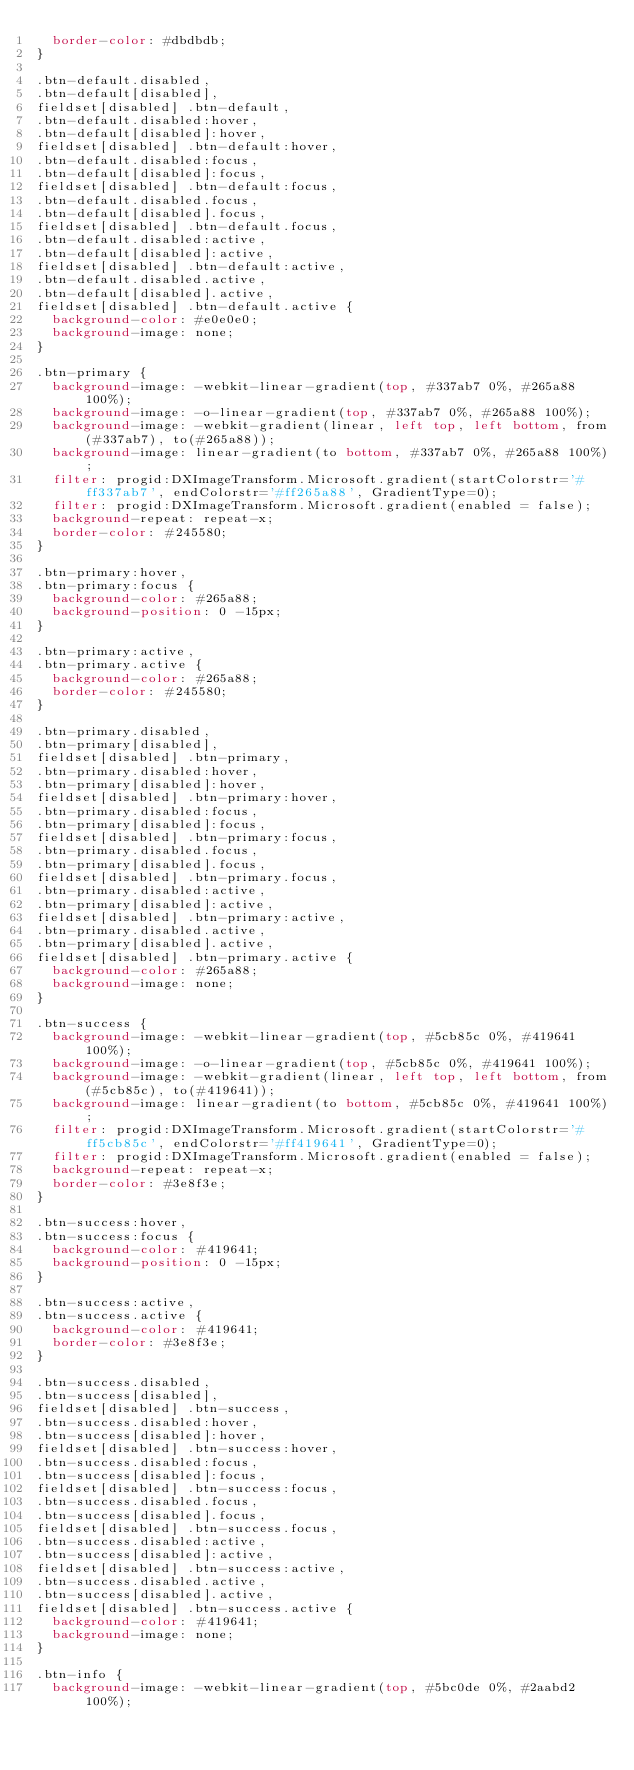Convert code to text. <code><loc_0><loc_0><loc_500><loc_500><_CSS_>  border-color: #dbdbdb;
}

.btn-default.disabled,
.btn-default[disabled],
fieldset[disabled] .btn-default,
.btn-default.disabled:hover,
.btn-default[disabled]:hover,
fieldset[disabled] .btn-default:hover,
.btn-default.disabled:focus,
.btn-default[disabled]:focus,
fieldset[disabled] .btn-default:focus,
.btn-default.disabled.focus,
.btn-default[disabled].focus,
fieldset[disabled] .btn-default.focus,
.btn-default.disabled:active,
.btn-default[disabled]:active,
fieldset[disabled] .btn-default:active,
.btn-default.disabled.active,
.btn-default[disabled].active,
fieldset[disabled] .btn-default.active {
  background-color: #e0e0e0;
  background-image: none;
}

.btn-primary {
  background-image: -webkit-linear-gradient(top, #337ab7 0%, #265a88 100%);
  background-image: -o-linear-gradient(top, #337ab7 0%, #265a88 100%);
  background-image: -webkit-gradient(linear, left top, left bottom, from(#337ab7), to(#265a88));
  background-image: linear-gradient(to bottom, #337ab7 0%, #265a88 100%);
  filter: progid:DXImageTransform.Microsoft.gradient(startColorstr='#ff337ab7', endColorstr='#ff265a88', GradientType=0);
  filter: progid:DXImageTransform.Microsoft.gradient(enabled = false);
  background-repeat: repeat-x;
  border-color: #245580;
}

.btn-primary:hover,
.btn-primary:focus {
  background-color: #265a88;
  background-position: 0 -15px;
}

.btn-primary:active,
.btn-primary.active {
  background-color: #265a88;
  border-color: #245580;
}

.btn-primary.disabled,
.btn-primary[disabled],
fieldset[disabled] .btn-primary,
.btn-primary.disabled:hover,
.btn-primary[disabled]:hover,
fieldset[disabled] .btn-primary:hover,
.btn-primary.disabled:focus,
.btn-primary[disabled]:focus,
fieldset[disabled] .btn-primary:focus,
.btn-primary.disabled.focus,
.btn-primary[disabled].focus,
fieldset[disabled] .btn-primary.focus,
.btn-primary.disabled:active,
.btn-primary[disabled]:active,
fieldset[disabled] .btn-primary:active,
.btn-primary.disabled.active,
.btn-primary[disabled].active,
fieldset[disabled] .btn-primary.active {
  background-color: #265a88;
  background-image: none;
}

.btn-success {
  background-image: -webkit-linear-gradient(top, #5cb85c 0%, #419641 100%);
  background-image: -o-linear-gradient(top, #5cb85c 0%, #419641 100%);
  background-image: -webkit-gradient(linear, left top, left bottom, from(#5cb85c), to(#419641));
  background-image: linear-gradient(to bottom, #5cb85c 0%, #419641 100%);
  filter: progid:DXImageTransform.Microsoft.gradient(startColorstr='#ff5cb85c', endColorstr='#ff419641', GradientType=0);
  filter: progid:DXImageTransform.Microsoft.gradient(enabled = false);
  background-repeat: repeat-x;
  border-color: #3e8f3e;
}

.btn-success:hover,
.btn-success:focus {
  background-color: #419641;
  background-position: 0 -15px;
}

.btn-success:active,
.btn-success.active {
  background-color: #419641;
  border-color: #3e8f3e;
}

.btn-success.disabled,
.btn-success[disabled],
fieldset[disabled] .btn-success,
.btn-success.disabled:hover,
.btn-success[disabled]:hover,
fieldset[disabled] .btn-success:hover,
.btn-success.disabled:focus,
.btn-success[disabled]:focus,
fieldset[disabled] .btn-success:focus,
.btn-success.disabled.focus,
.btn-success[disabled].focus,
fieldset[disabled] .btn-success.focus,
.btn-success.disabled:active,
.btn-success[disabled]:active,
fieldset[disabled] .btn-success:active,
.btn-success.disabled.active,
.btn-success[disabled].active,
fieldset[disabled] .btn-success.active {
  background-color: #419641;
  background-image: none;
}

.btn-info {
  background-image: -webkit-linear-gradient(top, #5bc0de 0%, #2aabd2 100%);</code> 